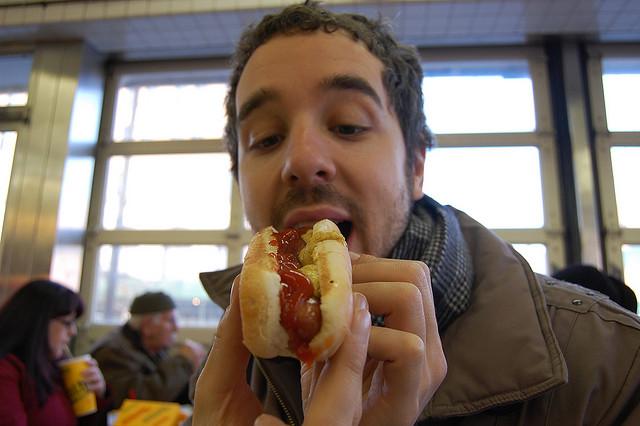What condiments are on the hot dog?
Give a very brief answer. Ketchup and mustard. Does the person eating have facial hair?
Concise answer only. Yes. What is the man eating?
Keep it brief. Hot dog. What is the woman in the background doing?
Answer briefly. Drinking. 